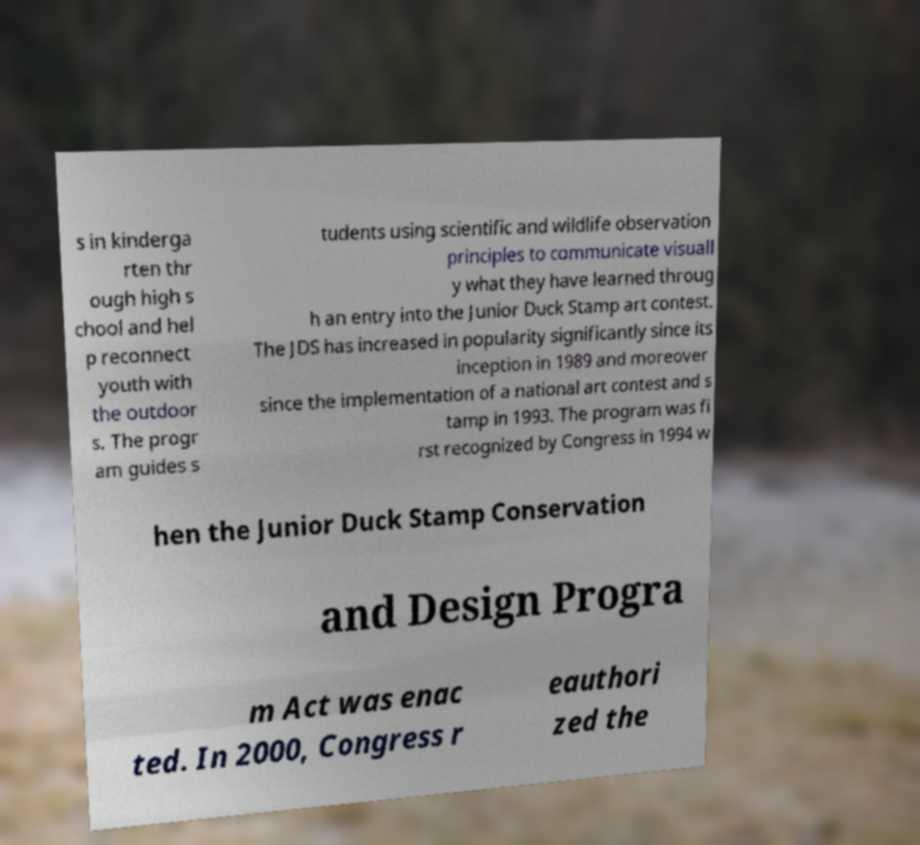There's text embedded in this image that I need extracted. Can you transcribe it verbatim? s in kinderga rten thr ough high s chool and hel p reconnect youth with the outdoor s. The progr am guides s tudents using scientific and wildlife observation principles to communicate visuall y what they have learned throug h an entry into the Junior Duck Stamp art contest. The JDS has increased in popularity significantly since its inception in 1989 and moreover since the implementation of a national art contest and s tamp in 1993. The program was fi rst recognized by Congress in 1994 w hen the Junior Duck Stamp Conservation and Design Progra m Act was enac ted. In 2000, Congress r eauthori zed the 